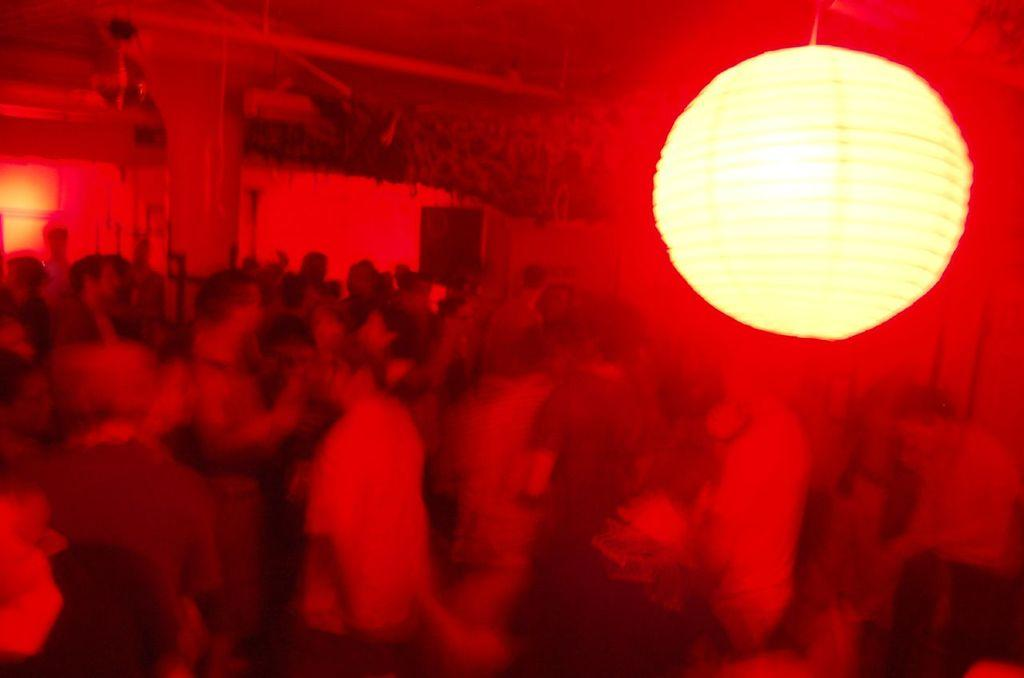How many people are in the image? There is a group of people in the image. Where are the people located in the image? The people are in a path. What is the overall color tone of the image? The image has a red color tone. What can be seen in the background of the image? There is a pillar and a wall in the background of the image. What is the source of light visible at the top of the image? There is a light visible at the top of the image. What type of sound can be heard coming from the spade in the image? There is no spade present in the image, so it is not possible to determine what, if any, sound might be heard. 